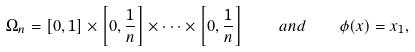Convert formula to latex. <formula><loc_0><loc_0><loc_500><loc_500>\Omega _ { n } = [ 0 , 1 ] \times \left [ 0 , \frac { 1 } { n } \right ] \times \dots \times \left [ 0 , \frac { 1 } { n } \right ] \quad a n d \quad \phi ( x ) = x _ { 1 } ,</formula> 